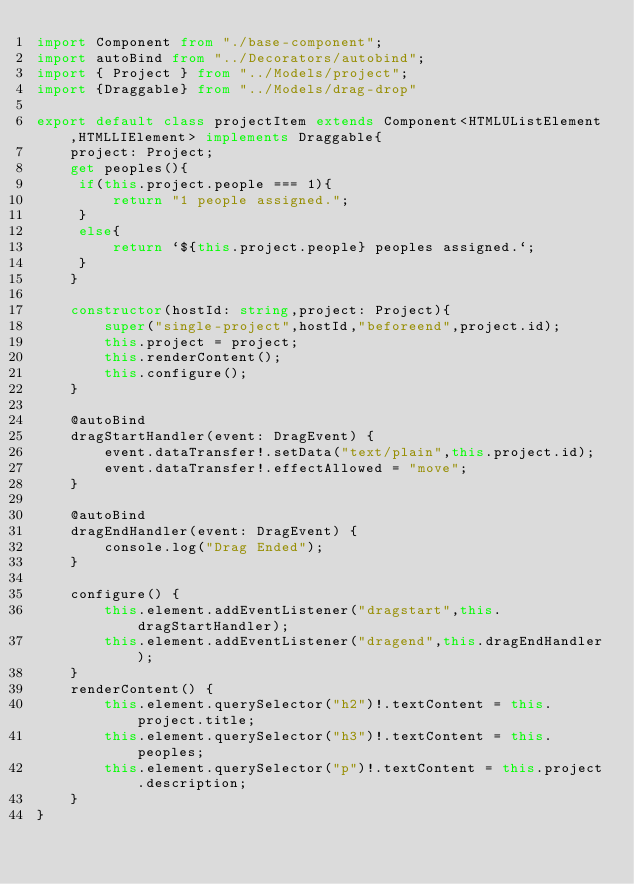<code> <loc_0><loc_0><loc_500><loc_500><_TypeScript_>import Component from "./base-component";
import autoBind from "../Decorators/autobind";
import { Project } from "../Models/project";
import {Draggable} from "../Models/drag-drop"

export default class projectItem extends Component<HTMLUListElement,HTMLLIElement> implements Draggable{
    project: Project;
    get peoples(){
     if(this.project.people === 1){
         return "1 people assigned.";
     }
     else{
         return `${this.project.people} peoples assigned.`;
     }
    }

    constructor(hostId: string,project: Project){
        super("single-project",hostId,"beforeend",project.id);
        this.project = project;
        this.renderContent();
        this.configure();
    }

    @autoBind
    dragStartHandler(event: DragEvent) {
        event.dataTransfer!.setData("text/plain",this.project.id);
        event.dataTransfer!.effectAllowed = "move";
    }

    @autoBind
    dragEndHandler(event: DragEvent) {
        console.log("Drag Ended");
    }

    configure() {
        this.element.addEventListener("dragstart",this.dragStartHandler);
        this.element.addEventListener("dragend",this.dragEndHandler);
    }
    renderContent() {
        this.element.querySelector("h2")!.textContent = this.project.title;
        this.element.querySelector("h3")!.textContent = this.peoples;
        this.element.querySelector("p")!.textContent = this.project.description;
    }
}</code> 